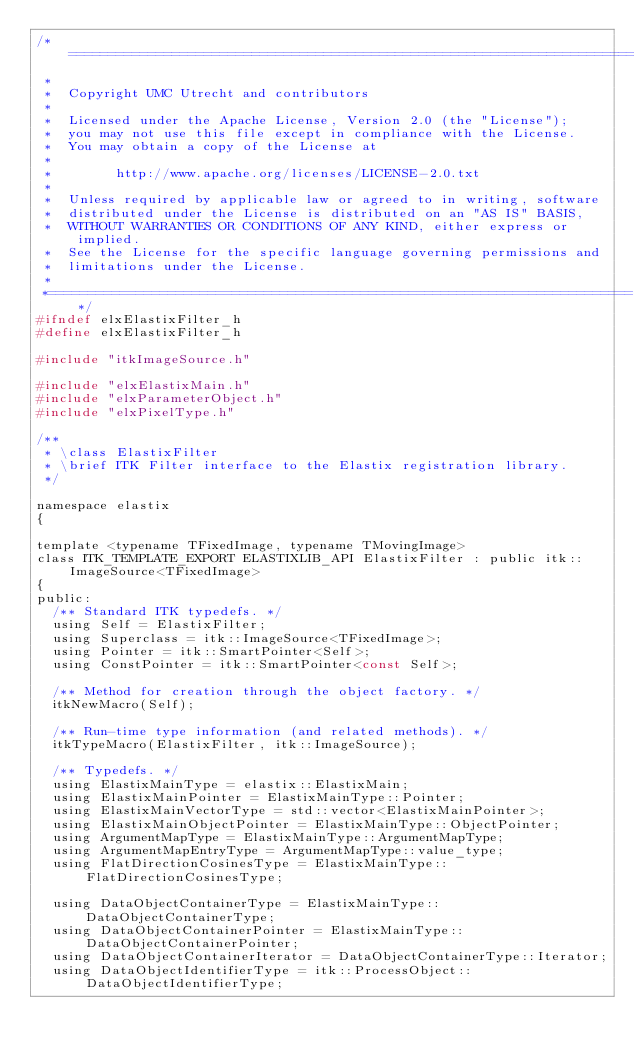<code> <loc_0><loc_0><loc_500><loc_500><_C_>/*=========================================================================
 *
 *  Copyright UMC Utrecht and contributors
 *
 *  Licensed under the Apache License, Version 2.0 (the "License");
 *  you may not use this file except in compliance with the License.
 *  You may obtain a copy of the License at
 *
 *        http://www.apache.org/licenses/LICENSE-2.0.txt
 *
 *  Unless required by applicable law or agreed to in writing, software
 *  distributed under the License is distributed on an "AS IS" BASIS,
 *  WITHOUT WARRANTIES OR CONDITIONS OF ANY KIND, either express or implied.
 *  See the License for the specific language governing permissions and
 *  limitations under the License.
 *
 *=========================================================================*/
#ifndef elxElastixFilter_h
#define elxElastixFilter_h

#include "itkImageSource.h"

#include "elxElastixMain.h"
#include "elxParameterObject.h"
#include "elxPixelType.h"

/**
 * \class ElastixFilter
 * \brief ITK Filter interface to the Elastix registration library.
 */

namespace elastix
{

template <typename TFixedImage, typename TMovingImage>
class ITK_TEMPLATE_EXPORT ELASTIXLIB_API ElastixFilter : public itk::ImageSource<TFixedImage>
{
public:
  /** Standard ITK typedefs. */
  using Self = ElastixFilter;
  using Superclass = itk::ImageSource<TFixedImage>;
  using Pointer = itk::SmartPointer<Self>;
  using ConstPointer = itk::SmartPointer<const Self>;

  /** Method for creation through the object factory. */
  itkNewMacro(Self);

  /** Run-time type information (and related methods). */
  itkTypeMacro(ElastixFilter, itk::ImageSource);

  /** Typedefs. */
  using ElastixMainType = elastix::ElastixMain;
  using ElastixMainPointer = ElastixMainType::Pointer;
  using ElastixMainVectorType = std::vector<ElastixMainPointer>;
  using ElastixMainObjectPointer = ElastixMainType::ObjectPointer;
  using ArgumentMapType = ElastixMainType::ArgumentMapType;
  using ArgumentMapEntryType = ArgumentMapType::value_type;
  using FlatDirectionCosinesType = ElastixMainType::FlatDirectionCosinesType;

  using DataObjectContainerType = ElastixMainType::DataObjectContainerType;
  using DataObjectContainerPointer = ElastixMainType::DataObjectContainerPointer;
  using DataObjectContainerIterator = DataObjectContainerType::Iterator;
  using DataObjectIdentifierType = itk::ProcessObject::DataObjectIdentifierType;</code> 